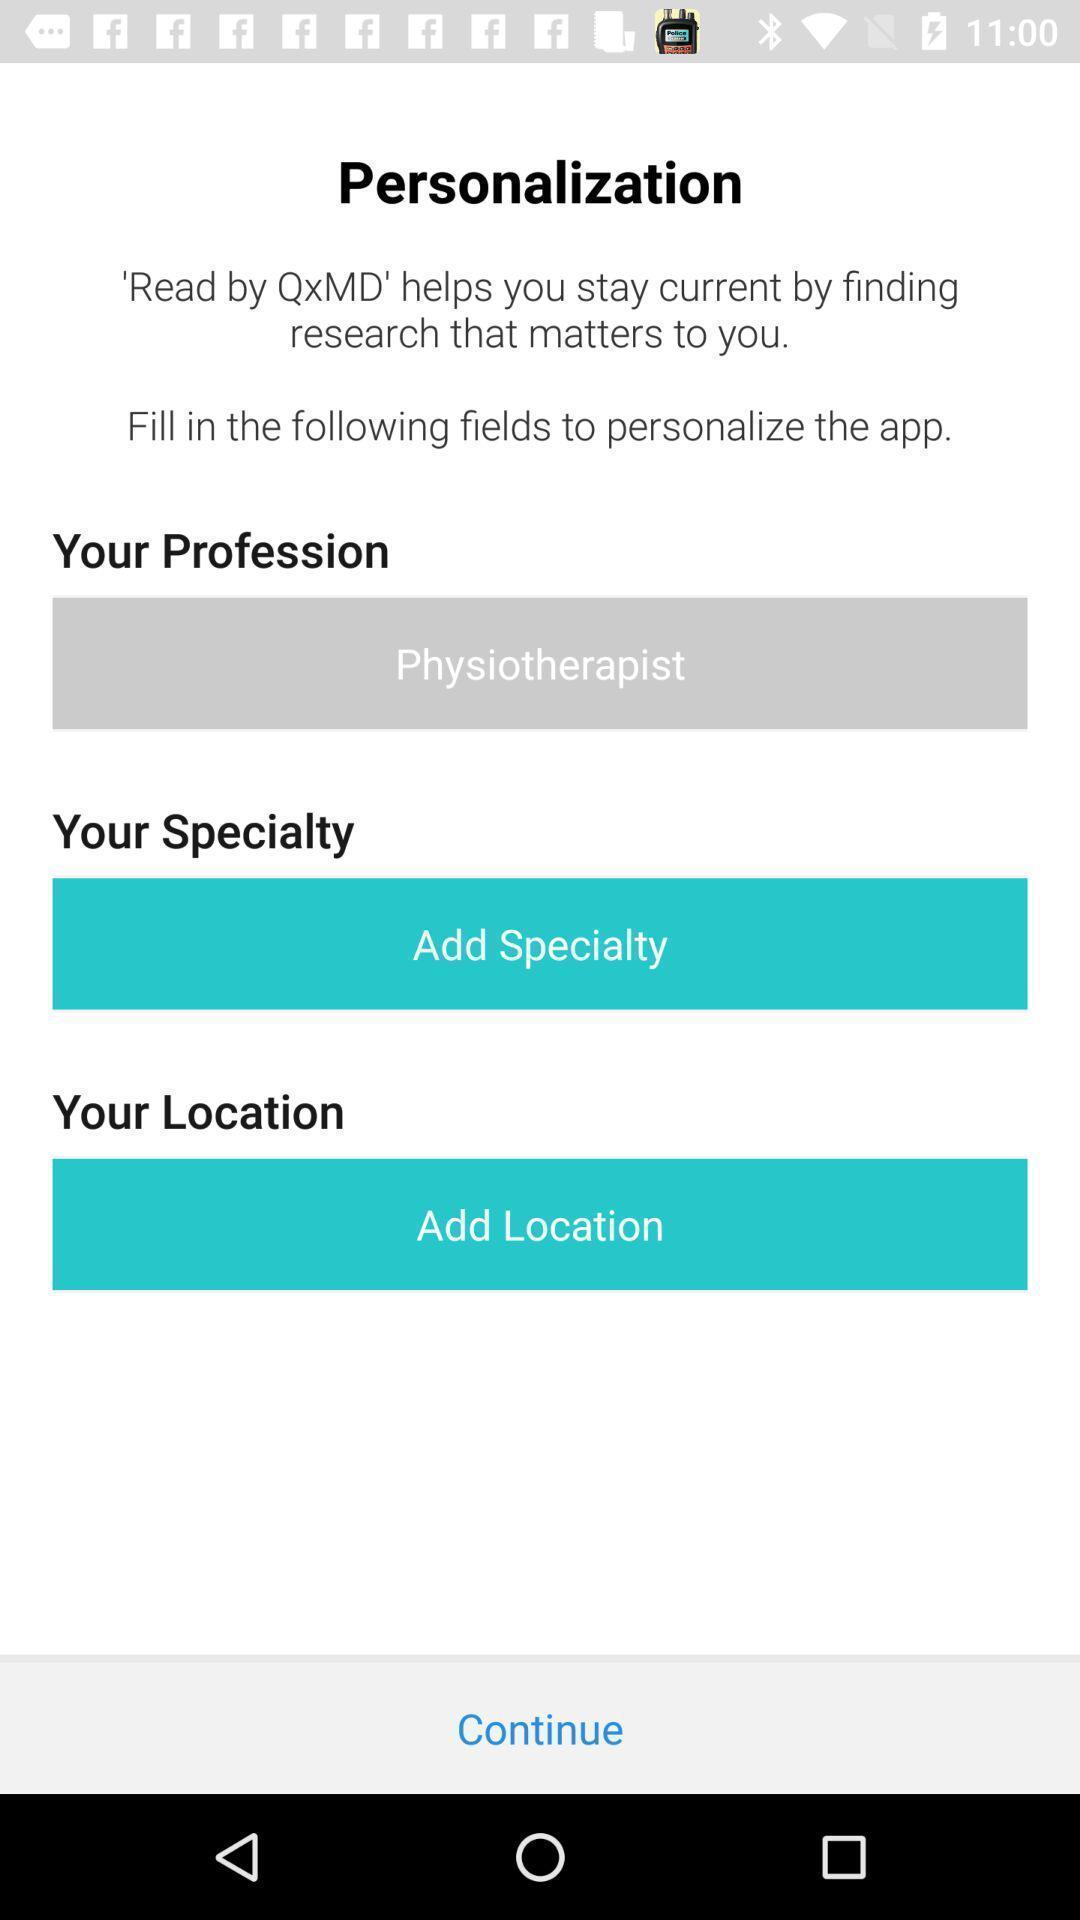What can you discern from this picture? Welcome page for a medical researches related app. 